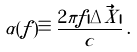<formula> <loc_0><loc_0><loc_500><loc_500>\alpha ( f ) \equiv \frac { 2 \pi f | \Delta \vec { X } | } { c } \, .</formula> 